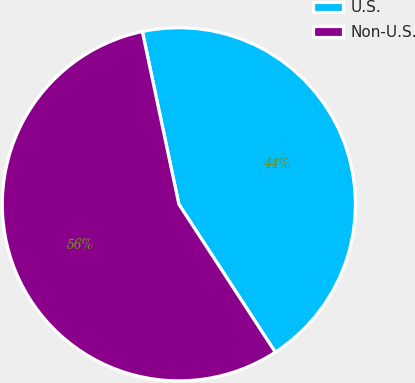Convert chart. <chart><loc_0><loc_0><loc_500><loc_500><pie_chart><fcel>U.S.<fcel>Non-U.S.<nl><fcel>44.12%<fcel>55.88%<nl></chart> 